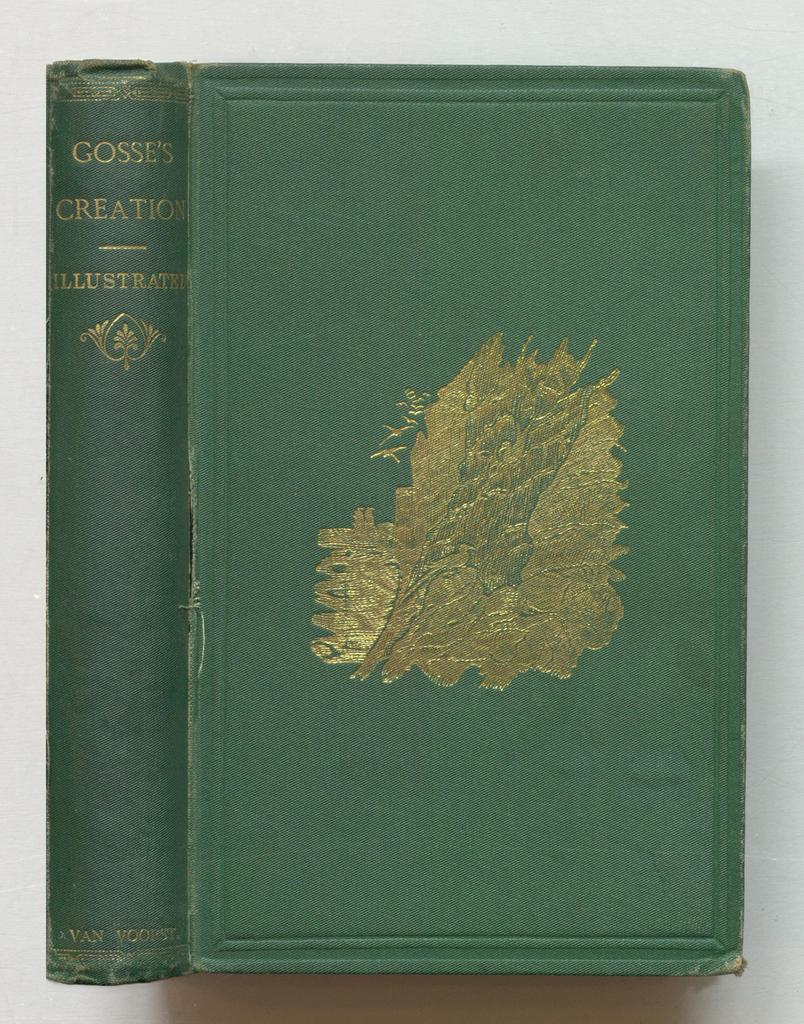Provide a one-sentence caption for the provided image. A green book says Gosse's Creation Illustrated on the binding. 